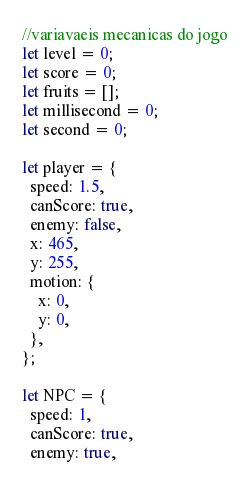Convert code to text. <code><loc_0><loc_0><loc_500><loc_500><_JavaScript_>//variavaeis mecanicas do jogo
let level = 0;
let score = 0;
let fruits = [];
let millisecond = 0;
let second = 0;

let player = {
  speed: 1.5,
  canScore: true,
  enemy: false,
  x: 465,
  y: 255,
  motion: {
    x: 0,
    y: 0,
  },
};

let NPC = {
  speed: 1,
  canScore: true,
  enemy: true,</code> 